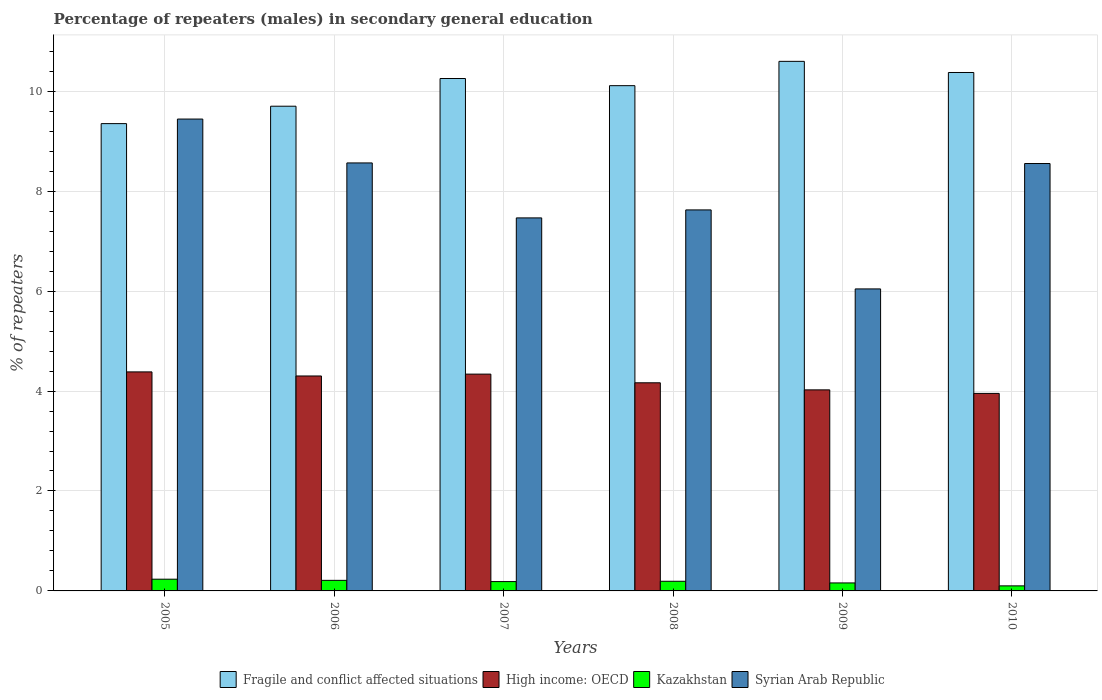How many different coloured bars are there?
Offer a terse response. 4. How many groups of bars are there?
Provide a succinct answer. 6. Are the number of bars on each tick of the X-axis equal?
Provide a succinct answer. Yes. How many bars are there on the 1st tick from the left?
Ensure brevity in your answer.  4. What is the label of the 1st group of bars from the left?
Make the answer very short. 2005. In how many cases, is the number of bars for a given year not equal to the number of legend labels?
Your answer should be very brief. 0. What is the percentage of male repeaters in High income: OECD in 2008?
Provide a succinct answer. 4.17. Across all years, what is the maximum percentage of male repeaters in Fragile and conflict affected situations?
Your response must be concise. 10.6. Across all years, what is the minimum percentage of male repeaters in High income: OECD?
Your answer should be compact. 3.95. What is the total percentage of male repeaters in Syrian Arab Republic in the graph?
Make the answer very short. 47.7. What is the difference between the percentage of male repeaters in High income: OECD in 2006 and that in 2009?
Your response must be concise. 0.28. What is the difference between the percentage of male repeaters in Fragile and conflict affected situations in 2005 and the percentage of male repeaters in Kazakhstan in 2006?
Provide a succinct answer. 9.14. What is the average percentage of male repeaters in Syrian Arab Republic per year?
Your answer should be very brief. 7.95. In the year 2006, what is the difference between the percentage of male repeaters in Syrian Arab Republic and percentage of male repeaters in High income: OECD?
Provide a short and direct response. 4.26. In how many years, is the percentage of male repeaters in Syrian Arab Republic greater than 0.4 %?
Offer a terse response. 6. What is the ratio of the percentage of male repeaters in Kazakhstan in 2005 to that in 2007?
Provide a short and direct response. 1.26. Is the difference between the percentage of male repeaters in Syrian Arab Republic in 2006 and 2009 greater than the difference between the percentage of male repeaters in High income: OECD in 2006 and 2009?
Give a very brief answer. Yes. What is the difference between the highest and the second highest percentage of male repeaters in Kazakhstan?
Ensure brevity in your answer.  0.02. What is the difference between the highest and the lowest percentage of male repeaters in Syrian Arab Republic?
Provide a succinct answer. 3.4. What does the 3rd bar from the left in 2009 represents?
Offer a very short reply. Kazakhstan. What does the 4th bar from the right in 2009 represents?
Your answer should be compact. Fragile and conflict affected situations. Is it the case that in every year, the sum of the percentage of male repeaters in High income: OECD and percentage of male repeaters in Syrian Arab Republic is greater than the percentage of male repeaters in Kazakhstan?
Your answer should be compact. Yes. What is the difference between two consecutive major ticks on the Y-axis?
Your response must be concise. 2. Does the graph contain grids?
Your answer should be compact. Yes. How many legend labels are there?
Your answer should be very brief. 4. How are the legend labels stacked?
Provide a succinct answer. Horizontal. What is the title of the graph?
Offer a terse response. Percentage of repeaters (males) in secondary general education. What is the label or title of the Y-axis?
Make the answer very short. % of repeaters. What is the % of repeaters in Fragile and conflict affected situations in 2005?
Your answer should be very brief. 9.35. What is the % of repeaters in High income: OECD in 2005?
Your answer should be very brief. 4.38. What is the % of repeaters of Kazakhstan in 2005?
Keep it short and to the point. 0.23. What is the % of repeaters of Syrian Arab Republic in 2005?
Your answer should be compact. 9.44. What is the % of repeaters in Fragile and conflict affected situations in 2006?
Offer a terse response. 9.7. What is the % of repeaters of High income: OECD in 2006?
Keep it short and to the point. 4.3. What is the % of repeaters of Kazakhstan in 2006?
Your response must be concise. 0.21. What is the % of repeaters of Syrian Arab Republic in 2006?
Provide a succinct answer. 8.57. What is the % of repeaters of Fragile and conflict affected situations in 2007?
Make the answer very short. 10.25. What is the % of repeaters in High income: OECD in 2007?
Offer a terse response. 4.34. What is the % of repeaters of Kazakhstan in 2007?
Offer a very short reply. 0.19. What is the % of repeaters in Syrian Arab Republic in 2007?
Ensure brevity in your answer.  7.47. What is the % of repeaters of Fragile and conflict affected situations in 2008?
Offer a terse response. 10.11. What is the % of repeaters in High income: OECD in 2008?
Your answer should be very brief. 4.17. What is the % of repeaters of Kazakhstan in 2008?
Ensure brevity in your answer.  0.19. What is the % of repeaters of Syrian Arab Republic in 2008?
Give a very brief answer. 7.63. What is the % of repeaters of Fragile and conflict affected situations in 2009?
Your response must be concise. 10.6. What is the % of repeaters of High income: OECD in 2009?
Your answer should be very brief. 4.02. What is the % of repeaters of Kazakhstan in 2009?
Offer a very short reply. 0.16. What is the % of repeaters in Syrian Arab Republic in 2009?
Give a very brief answer. 6.04. What is the % of repeaters in Fragile and conflict affected situations in 2010?
Offer a terse response. 10.38. What is the % of repeaters in High income: OECD in 2010?
Ensure brevity in your answer.  3.95. What is the % of repeaters in Kazakhstan in 2010?
Keep it short and to the point. 0.1. What is the % of repeaters in Syrian Arab Republic in 2010?
Offer a terse response. 8.55. Across all years, what is the maximum % of repeaters in Fragile and conflict affected situations?
Make the answer very short. 10.6. Across all years, what is the maximum % of repeaters of High income: OECD?
Make the answer very short. 4.38. Across all years, what is the maximum % of repeaters in Kazakhstan?
Your answer should be compact. 0.23. Across all years, what is the maximum % of repeaters in Syrian Arab Republic?
Your answer should be compact. 9.44. Across all years, what is the minimum % of repeaters in Fragile and conflict affected situations?
Your answer should be compact. 9.35. Across all years, what is the minimum % of repeaters in High income: OECD?
Provide a succinct answer. 3.95. Across all years, what is the minimum % of repeaters in Kazakhstan?
Your response must be concise. 0.1. Across all years, what is the minimum % of repeaters of Syrian Arab Republic?
Your response must be concise. 6.04. What is the total % of repeaters of Fragile and conflict affected situations in the graph?
Your response must be concise. 60.39. What is the total % of repeaters of High income: OECD in the graph?
Your response must be concise. 25.17. What is the total % of repeaters of Kazakhstan in the graph?
Your answer should be very brief. 1.09. What is the total % of repeaters of Syrian Arab Republic in the graph?
Provide a short and direct response. 47.7. What is the difference between the % of repeaters of Fragile and conflict affected situations in 2005 and that in 2006?
Your response must be concise. -0.35. What is the difference between the % of repeaters of High income: OECD in 2005 and that in 2006?
Your response must be concise. 0.08. What is the difference between the % of repeaters of Kazakhstan in 2005 and that in 2006?
Your answer should be compact. 0.02. What is the difference between the % of repeaters of Syrian Arab Republic in 2005 and that in 2006?
Your answer should be very brief. 0.88. What is the difference between the % of repeaters in Fragile and conflict affected situations in 2005 and that in 2007?
Give a very brief answer. -0.9. What is the difference between the % of repeaters in High income: OECD in 2005 and that in 2007?
Provide a succinct answer. 0.04. What is the difference between the % of repeaters in Kazakhstan in 2005 and that in 2007?
Make the answer very short. 0.05. What is the difference between the % of repeaters of Syrian Arab Republic in 2005 and that in 2007?
Give a very brief answer. 1.98. What is the difference between the % of repeaters in Fragile and conflict affected situations in 2005 and that in 2008?
Provide a short and direct response. -0.76. What is the difference between the % of repeaters in High income: OECD in 2005 and that in 2008?
Offer a terse response. 0.22. What is the difference between the % of repeaters of Kazakhstan in 2005 and that in 2008?
Offer a terse response. 0.04. What is the difference between the % of repeaters of Syrian Arab Republic in 2005 and that in 2008?
Offer a terse response. 1.82. What is the difference between the % of repeaters of Fragile and conflict affected situations in 2005 and that in 2009?
Your response must be concise. -1.25. What is the difference between the % of repeaters of High income: OECD in 2005 and that in 2009?
Your answer should be compact. 0.36. What is the difference between the % of repeaters of Kazakhstan in 2005 and that in 2009?
Your answer should be very brief. 0.07. What is the difference between the % of repeaters of Syrian Arab Republic in 2005 and that in 2009?
Ensure brevity in your answer.  3.4. What is the difference between the % of repeaters of Fragile and conflict affected situations in 2005 and that in 2010?
Give a very brief answer. -1.02. What is the difference between the % of repeaters of High income: OECD in 2005 and that in 2010?
Your response must be concise. 0.43. What is the difference between the % of repeaters in Kazakhstan in 2005 and that in 2010?
Offer a very short reply. 0.13. What is the difference between the % of repeaters of Syrian Arab Republic in 2005 and that in 2010?
Provide a succinct answer. 0.89. What is the difference between the % of repeaters in Fragile and conflict affected situations in 2006 and that in 2007?
Provide a succinct answer. -0.55. What is the difference between the % of repeaters in High income: OECD in 2006 and that in 2007?
Offer a very short reply. -0.04. What is the difference between the % of repeaters in Kazakhstan in 2006 and that in 2007?
Your answer should be compact. 0.02. What is the difference between the % of repeaters in Syrian Arab Republic in 2006 and that in 2007?
Offer a terse response. 1.1. What is the difference between the % of repeaters in Fragile and conflict affected situations in 2006 and that in 2008?
Make the answer very short. -0.41. What is the difference between the % of repeaters in High income: OECD in 2006 and that in 2008?
Ensure brevity in your answer.  0.14. What is the difference between the % of repeaters of Kazakhstan in 2006 and that in 2008?
Provide a short and direct response. 0.02. What is the difference between the % of repeaters of Syrian Arab Republic in 2006 and that in 2008?
Keep it short and to the point. 0.94. What is the difference between the % of repeaters of Fragile and conflict affected situations in 2006 and that in 2009?
Make the answer very short. -0.9. What is the difference between the % of repeaters in High income: OECD in 2006 and that in 2009?
Make the answer very short. 0.28. What is the difference between the % of repeaters of Kazakhstan in 2006 and that in 2009?
Your answer should be compact. 0.05. What is the difference between the % of repeaters in Syrian Arab Republic in 2006 and that in 2009?
Your response must be concise. 2.52. What is the difference between the % of repeaters of Fragile and conflict affected situations in 2006 and that in 2010?
Your answer should be compact. -0.67. What is the difference between the % of repeaters of High income: OECD in 2006 and that in 2010?
Keep it short and to the point. 0.35. What is the difference between the % of repeaters in Kazakhstan in 2006 and that in 2010?
Give a very brief answer. 0.11. What is the difference between the % of repeaters in Syrian Arab Republic in 2006 and that in 2010?
Provide a succinct answer. 0.01. What is the difference between the % of repeaters in Fragile and conflict affected situations in 2007 and that in 2008?
Make the answer very short. 0.14. What is the difference between the % of repeaters of High income: OECD in 2007 and that in 2008?
Offer a very short reply. 0.17. What is the difference between the % of repeaters in Kazakhstan in 2007 and that in 2008?
Give a very brief answer. -0.01. What is the difference between the % of repeaters of Syrian Arab Republic in 2007 and that in 2008?
Offer a very short reply. -0.16. What is the difference between the % of repeaters in Fragile and conflict affected situations in 2007 and that in 2009?
Your answer should be compact. -0.34. What is the difference between the % of repeaters of High income: OECD in 2007 and that in 2009?
Give a very brief answer. 0.32. What is the difference between the % of repeaters in Kazakhstan in 2007 and that in 2009?
Ensure brevity in your answer.  0.03. What is the difference between the % of repeaters of Syrian Arab Republic in 2007 and that in 2009?
Your answer should be very brief. 1.42. What is the difference between the % of repeaters of Fragile and conflict affected situations in 2007 and that in 2010?
Offer a very short reply. -0.12. What is the difference between the % of repeaters of High income: OECD in 2007 and that in 2010?
Provide a succinct answer. 0.39. What is the difference between the % of repeaters in Kazakhstan in 2007 and that in 2010?
Your answer should be very brief. 0.09. What is the difference between the % of repeaters of Syrian Arab Republic in 2007 and that in 2010?
Your answer should be compact. -1.09. What is the difference between the % of repeaters in Fragile and conflict affected situations in 2008 and that in 2009?
Your answer should be very brief. -0.49. What is the difference between the % of repeaters in High income: OECD in 2008 and that in 2009?
Offer a very short reply. 0.14. What is the difference between the % of repeaters of Kazakhstan in 2008 and that in 2009?
Give a very brief answer. 0.03. What is the difference between the % of repeaters in Syrian Arab Republic in 2008 and that in 2009?
Make the answer very short. 1.58. What is the difference between the % of repeaters of Fragile and conflict affected situations in 2008 and that in 2010?
Ensure brevity in your answer.  -0.26. What is the difference between the % of repeaters of High income: OECD in 2008 and that in 2010?
Provide a short and direct response. 0.21. What is the difference between the % of repeaters in Kazakhstan in 2008 and that in 2010?
Give a very brief answer. 0.09. What is the difference between the % of repeaters of Syrian Arab Republic in 2008 and that in 2010?
Make the answer very short. -0.93. What is the difference between the % of repeaters in Fragile and conflict affected situations in 2009 and that in 2010?
Ensure brevity in your answer.  0.22. What is the difference between the % of repeaters in High income: OECD in 2009 and that in 2010?
Offer a terse response. 0.07. What is the difference between the % of repeaters of Kazakhstan in 2009 and that in 2010?
Make the answer very short. 0.06. What is the difference between the % of repeaters in Syrian Arab Republic in 2009 and that in 2010?
Give a very brief answer. -2.51. What is the difference between the % of repeaters in Fragile and conflict affected situations in 2005 and the % of repeaters in High income: OECD in 2006?
Your answer should be compact. 5.05. What is the difference between the % of repeaters in Fragile and conflict affected situations in 2005 and the % of repeaters in Kazakhstan in 2006?
Provide a succinct answer. 9.14. What is the difference between the % of repeaters of Fragile and conflict affected situations in 2005 and the % of repeaters of Syrian Arab Republic in 2006?
Offer a very short reply. 0.79. What is the difference between the % of repeaters of High income: OECD in 2005 and the % of repeaters of Kazakhstan in 2006?
Make the answer very short. 4.17. What is the difference between the % of repeaters in High income: OECD in 2005 and the % of repeaters in Syrian Arab Republic in 2006?
Give a very brief answer. -4.18. What is the difference between the % of repeaters in Kazakhstan in 2005 and the % of repeaters in Syrian Arab Republic in 2006?
Offer a very short reply. -8.33. What is the difference between the % of repeaters in Fragile and conflict affected situations in 2005 and the % of repeaters in High income: OECD in 2007?
Keep it short and to the point. 5.01. What is the difference between the % of repeaters in Fragile and conflict affected situations in 2005 and the % of repeaters in Kazakhstan in 2007?
Your answer should be very brief. 9.17. What is the difference between the % of repeaters in Fragile and conflict affected situations in 2005 and the % of repeaters in Syrian Arab Republic in 2007?
Your answer should be very brief. 1.89. What is the difference between the % of repeaters of High income: OECD in 2005 and the % of repeaters of Kazakhstan in 2007?
Ensure brevity in your answer.  4.2. What is the difference between the % of repeaters in High income: OECD in 2005 and the % of repeaters in Syrian Arab Republic in 2007?
Offer a terse response. -3.08. What is the difference between the % of repeaters in Kazakhstan in 2005 and the % of repeaters in Syrian Arab Republic in 2007?
Provide a succinct answer. -7.23. What is the difference between the % of repeaters of Fragile and conflict affected situations in 2005 and the % of repeaters of High income: OECD in 2008?
Your answer should be very brief. 5.19. What is the difference between the % of repeaters in Fragile and conflict affected situations in 2005 and the % of repeaters in Kazakhstan in 2008?
Make the answer very short. 9.16. What is the difference between the % of repeaters of Fragile and conflict affected situations in 2005 and the % of repeaters of Syrian Arab Republic in 2008?
Ensure brevity in your answer.  1.73. What is the difference between the % of repeaters of High income: OECD in 2005 and the % of repeaters of Kazakhstan in 2008?
Offer a terse response. 4.19. What is the difference between the % of repeaters in High income: OECD in 2005 and the % of repeaters in Syrian Arab Republic in 2008?
Make the answer very short. -3.24. What is the difference between the % of repeaters of Kazakhstan in 2005 and the % of repeaters of Syrian Arab Republic in 2008?
Your answer should be compact. -7.39. What is the difference between the % of repeaters in Fragile and conflict affected situations in 2005 and the % of repeaters in High income: OECD in 2009?
Ensure brevity in your answer.  5.33. What is the difference between the % of repeaters of Fragile and conflict affected situations in 2005 and the % of repeaters of Kazakhstan in 2009?
Make the answer very short. 9.19. What is the difference between the % of repeaters in Fragile and conflict affected situations in 2005 and the % of repeaters in Syrian Arab Republic in 2009?
Offer a very short reply. 3.31. What is the difference between the % of repeaters in High income: OECD in 2005 and the % of repeaters in Kazakhstan in 2009?
Provide a short and direct response. 4.22. What is the difference between the % of repeaters of High income: OECD in 2005 and the % of repeaters of Syrian Arab Republic in 2009?
Your answer should be very brief. -1.66. What is the difference between the % of repeaters in Kazakhstan in 2005 and the % of repeaters in Syrian Arab Republic in 2009?
Provide a succinct answer. -5.81. What is the difference between the % of repeaters of Fragile and conflict affected situations in 2005 and the % of repeaters of High income: OECD in 2010?
Your answer should be very brief. 5.4. What is the difference between the % of repeaters in Fragile and conflict affected situations in 2005 and the % of repeaters in Kazakhstan in 2010?
Keep it short and to the point. 9.25. What is the difference between the % of repeaters of Fragile and conflict affected situations in 2005 and the % of repeaters of Syrian Arab Republic in 2010?
Offer a terse response. 0.8. What is the difference between the % of repeaters in High income: OECD in 2005 and the % of repeaters in Kazakhstan in 2010?
Ensure brevity in your answer.  4.28. What is the difference between the % of repeaters of High income: OECD in 2005 and the % of repeaters of Syrian Arab Republic in 2010?
Your response must be concise. -4.17. What is the difference between the % of repeaters of Kazakhstan in 2005 and the % of repeaters of Syrian Arab Republic in 2010?
Keep it short and to the point. -8.32. What is the difference between the % of repeaters in Fragile and conflict affected situations in 2006 and the % of repeaters in High income: OECD in 2007?
Offer a very short reply. 5.36. What is the difference between the % of repeaters in Fragile and conflict affected situations in 2006 and the % of repeaters in Kazakhstan in 2007?
Offer a terse response. 9.51. What is the difference between the % of repeaters in Fragile and conflict affected situations in 2006 and the % of repeaters in Syrian Arab Republic in 2007?
Ensure brevity in your answer.  2.24. What is the difference between the % of repeaters in High income: OECD in 2006 and the % of repeaters in Kazakhstan in 2007?
Offer a terse response. 4.11. What is the difference between the % of repeaters of High income: OECD in 2006 and the % of repeaters of Syrian Arab Republic in 2007?
Offer a terse response. -3.16. What is the difference between the % of repeaters of Kazakhstan in 2006 and the % of repeaters of Syrian Arab Republic in 2007?
Provide a succinct answer. -7.25. What is the difference between the % of repeaters of Fragile and conflict affected situations in 2006 and the % of repeaters of High income: OECD in 2008?
Provide a short and direct response. 5.54. What is the difference between the % of repeaters in Fragile and conflict affected situations in 2006 and the % of repeaters in Kazakhstan in 2008?
Ensure brevity in your answer.  9.51. What is the difference between the % of repeaters of Fragile and conflict affected situations in 2006 and the % of repeaters of Syrian Arab Republic in 2008?
Offer a terse response. 2.08. What is the difference between the % of repeaters of High income: OECD in 2006 and the % of repeaters of Kazakhstan in 2008?
Ensure brevity in your answer.  4.11. What is the difference between the % of repeaters of High income: OECD in 2006 and the % of repeaters of Syrian Arab Republic in 2008?
Offer a terse response. -3.32. What is the difference between the % of repeaters of Kazakhstan in 2006 and the % of repeaters of Syrian Arab Republic in 2008?
Offer a terse response. -7.41. What is the difference between the % of repeaters in Fragile and conflict affected situations in 2006 and the % of repeaters in High income: OECD in 2009?
Your answer should be very brief. 5.68. What is the difference between the % of repeaters of Fragile and conflict affected situations in 2006 and the % of repeaters of Kazakhstan in 2009?
Keep it short and to the point. 9.54. What is the difference between the % of repeaters in Fragile and conflict affected situations in 2006 and the % of repeaters in Syrian Arab Republic in 2009?
Provide a short and direct response. 3.66. What is the difference between the % of repeaters in High income: OECD in 2006 and the % of repeaters in Kazakhstan in 2009?
Provide a short and direct response. 4.14. What is the difference between the % of repeaters of High income: OECD in 2006 and the % of repeaters of Syrian Arab Republic in 2009?
Offer a very short reply. -1.74. What is the difference between the % of repeaters in Kazakhstan in 2006 and the % of repeaters in Syrian Arab Republic in 2009?
Offer a terse response. -5.83. What is the difference between the % of repeaters in Fragile and conflict affected situations in 2006 and the % of repeaters in High income: OECD in 2010?
Make the answer very short. 5.75. What is the difference between the % of repeaters of Fragile and conflict affected situations in 2006 and the % of repeaters of Kazakhstan in 2010?
Provide a succinct answer. 9.6. What is the difference between the % of repeaters in Fragile and conflict affected situations in 2006 and the % of repeaters in Syrian Arab Republic in 2010?
Your answer should be very brief. 1.15. What is the difference between the % of repeaters of High income: OECD in 2006 and the % of repeaters of Kazakhstan in 2010?
Offer a terse response. 4.2. What is the difference between the % of repeaters of High income: OECD in 2006 and the % of repeaters of Syrian Arab Republic in 2010?
Your answer should be compact. -4.25. What is the difference between the % of repeaters of Kazakhstan in 2006 and the % of repeaters of Syrian Arab Republic in 2010?
Offer a very short reply. -8.34. What is the difference between the % of repeaters of Fragile and conflict affected situations in 2007 and the % of repeaters of High income: OECD in 2008?
Make the answer very short. 6.09. What is the difference between the % of repeaters in Fragile and conflict affected situations in 2007 and the % of repeaters in Kazakhstan in 2008?
Provide a succinct answer. 10.06. What is the difference between the % of repeaters of Fragile and conflict affected situations in 2007 and the % of repeaters of Syrian Arab Republic in 2008?
Provide a succinct answer. 2.63. What is the difference between the % of repeaters of High income: OECD in 2007 and the % of repeaters of Kazakhstan in 2008?
Provide a succinct answer. 4.15. What is the difference between the % of repeaters in High income: OECD in 2007 and the % of repeaters in Syrian Arab Republic in 2008?
Provide a short and direct response. -3.29. What is the difference between the % of repeaters in Kazakhstan in 2007 and the % of repeaters in Syrian Arab Republic in 2008?
Offer a terse response. -7.44. What is the difference between the % of repeaters of Fragile and conflict affected situations in 2007 and the % of repeaters of High income: OECD in 2009?
Your answer should be compact. 6.23. What is the difference between the % of repeaters of Fragile and conflict affected situations in 2007 and the % of repeaters of Kazakhstan in 2009?
Your response must be concise. 10.09. What is the difference between the % of repeaters of Fragile and conflict affected situations in 2007 and the % of repeaters of Syrian Arab Republic in 2009?
Your answer should be very brief. 4.21. What is the difference between the % of repeaters of High income: OECD in 2007 and the % of repeaters of Kazakhstan in 2009?
Give a very brief answer. 4.18. What is the difference between the % of repeaters of High income: OECD in 2007 and the % of repeaters of Syrian Arab Republic in 2009?
Make the answer very short. -1.71. What is the difference between the % of repeaters in Kazakhstan in 2007 and the % of repeaters in Syrian Arab Republic in 2009?
Ensure brevity in your answer.  -5.86. What is the difference between the % of repeaters of Fragile and conflict affected situations in 2007 and the % of repeaters of High income: OECD in 2010?
Provide a short and direct response. 6.3. What is the difference between the % of repeaters of Fragile and conflict affected situations in 2007 and the % of repeaters of Kazakhstan in 2010?
Offer a terse response. 10.15. What is the difference between the % of repeaters of Fragile and conflict affected situations in 2007 and the % of repeaters of Syrian Arab Republic in 2010?
Keep it short and to the point. 1.7. What is the difference between the % of repeaters of High income: OECD in 2007 and the % of repeaters of Kazakhstan in 2010?
Provide a succinct answer. 4.24. What is the difference between the % of repeaters of High income: OECD in 2007 and the % of repeaters of Syrian Arab Republic in 2010?
Your response must be concise. -4.21. What is the difference between the % of repeaters of Kazakhstan in 2007 and the % of repeaters of Syrian Arab Republic in 2010?
Provide a succinct answer. -8.37. What is the difference between the % of repeaters in Fragile and conflict affected situations in 2008 and the % of repeaters in High income: OECD in 2009?
Give a very brief answer. 6.09. What is the difference between the % of repeaters of Fragile and conflict affected situations in 2008 and the % of repeaters of Kazakhstan in 2009?
Your answer should be very brief. 9.95. What is the difference between the % of repeaters in Fragile and conflict affected situations in 2008 and the % of repeaters in Syrian Arab Republic in 2009?
Ensure brevity in your answer.  4.07. What is the difference between the % of repeaters of High income: OECD in 2008 and the % of repeaters of Kazakhstan in 2009?
Ensure brevity in your answer.  4.01. What is the difference between the % of repeaters in High income: OECD in 2008 and the % of repeaters in Syrian Arab Republic in 2009?
Your answer should be compact. -1.88. What is the difference between the % of repeaters in Kazakhstan in 2008 and the % of repeaters in Syrian Arab Republic in 2009?
Your answer should be very brief. -5.85. What is the difference between the % of repeaters of Fragile and conflict affected situations in 2008 and the % of repeaters of High income: OECD in 2010?
Provide a short and direct response. 6.16. What is the difference between the % of repeaters of Fragile and conflict affected situations in 2008 and the % of repeaters of Kazakhstan in 2010?
Your answer should be compact. 10.01. What is the difference between the % of repeaters in Fragile and conflict affected situations in 2008 and the % of repeaters in Syrian Arab Republic in 2010?
Provide a short and direct response. 1.56. What is the difference between the % of repeaters in High income: OECD in 2008 and the % of repeaters in Kazakhstan in 2010?
Make the answer very short. 4.06. What is the difference between the % of repeaters in High income: OECD in 2008 and the % of repeaters in Syrian Arab Republic in 2010?
Provide a short and direct response. -4.39. What is the difference between the % of repeaters in Kazakhstan in 2008 and the % of repeaters in Syrian Arab Republic in 2010?
Give a very brief answer. -8.36. What is the difference between the % of repeaters in Fragile and conflict affected situations in 2009 and the % of repeaters in High income: OECD in 2010?
Your answer should be compact. 6.65. What is the difference between the % of repeaters of Fragile and conflict affected situations in 2009 and the % of repeaters of Kazakhstan in 2010?
Offer a very short reply. 10.5. What is the difference between the % of repeaters in Fragile and conflict affected situations in 2009 and the % of repeaters in Syrian Arab Republic in 2010?
Your response must be concise. 2.04. What is the difference between the % of repeaters in High income: OECD in 2009 and the % of repeaters in Kazakhstan in 2010?
Your answer should be very brief. 3.92. What is the difference between the % of repeaters of High income: OECD in 2009 and the % of repeaters of Syrian Arab Republic in 2010?
Your response must be concise. -4.53. What is the difference between the % of repeaters in Kazakhstan in 2009 and the % of repeaters in Syrian Arab Republic in 2010?
Your response must be concise. -8.39. What is the average % of repeaters of Fragile and conflict affected situations per year?
Keep it short and to the point. 10.07. What is the average % of repeaters in High income: OECD per year?
Give a very brief answer. 4.19. What is the average % of repeaters of Kazakhstan per year?
Your response must be concise. 0.18. What is the average % of repeaters of Syrian Arab Republic per year?
Provide a succinct answer. 7.95. In the year 2005, what is the difference between the % of repeaters in Fragile and conflict affected situations and % of repeaters in High income: OECD?
Your answer should be very brief. 4.97. In the year 2005, what is the difference between the % of repeaters of Fragile and conflict affected situations and % of repeaters of Kazakhstan?
Make the answer very short. 9.12. In the year 2005, what is the difference between the % of repeaters of Fragile and conflict affected situations and % of repeaters of Syrian Arab Republic?
Your answer should be very brief. -0.09. In the year 2005, what is the difference between the % of repeaters in High income: OECD and % of repeaters in Kazakhstan?
Provide a succinct answer. 4.15. In the year 2005, what is the difference between the % of repeaters in High income: OECD and % of repeaters in Syrian Arab Republic?
Give a very brief answer. -5.06. In the year 2005, what is the difference between the % of repeaters of Kazakhstan and % of repeaters of Syrian Arab Republic?
Give a very brief answer. -9.21. In the year 2006, what is the difference between the % of repeaters in Fragile and conflict affected situations and % of repeaters in High income: OECD?
Offer a terse response. 5.4. In the year 2006, what is the difference between the % of repeaters in Fragile and conflict affected situations and % of repeaters in Kazakhstan?
Ensure brevity in your answer.  9.49. In the year 2006, what is the difference between the % of repeaters in Fragile and conflict affected situations and % of repeaters in Syrian Arab Republic?
Give a very brief answer. 1.14. In the year 2006, what is the difference between the % of repeaters of High income: OECD and % of repeaters of Kazakhstan?
Provide a succinct answer. 4.09. In the year 2006, what is the difference between the % of repeaters in High income: OECD and % of repeaters in Syrian Arab Republic?
Your answer should be very brief. -4.26. In the year 2006, what is the difference between the % of repeaters in Kazakhstan and % of repeaters in Syrian Arab Republic?
Make the answer very short. -8.35. In the year 2007, what is the difference between the % of repeaters in Fragile and conflict affected situations and % of repeaters in High income: OECD?
Ensure brevity in your answer.  5.92. In the year 2007, what is the difference between the % of repeaters of Fragile and conflict affected situations and % of repeaters of Kazakhstan?
Ensure brevity in your answer.  10.07. In the year 2007, what is the difference between the % of repeaters in Fragile and conflict affected situations and % of repeaters in Syrian Arab Republic?
Offer a very short reply. 2.79. In the year 2007, what is the difference between the % of repeaters of High income: OECD and % of repeaters of Kazakhstan?
Give a very brief answer. 4.15. In the year 2007, what is the difference between the % of repeaters in High income: OECD and % of repeaters in Syrian Arab Republic?
Keep it short and to the point. -3.13. In the year 2007, what is the difference between the % of repeaters of Kazakhstan and % of repeaters of Syrian Arab Republic?
Make the answer very short. -7.28. In the year 2008, what is the difference between the % of repeaters in Fragile and conflict affected situations and % of repeaters in High income: OECD?
Offer a terse response. 5.95. In the year 2008, what is the difference between the % of repeaters of Fragile and conflict affected situations and % of repeaters of Kazakhstan?
Give a very brief answer. 9.92. In the year 2008, what is the difference between the % of repeaters in Fragile and conflict affected situations and % of repeaters in Syrian Arab Republic?
Ensure brevity in your answer.  2.49. In the year 2008, what is the difference between the % of repeaters in High income: OECD and % of repeaters in Kazakhstan?
Your response must be concise. 3.97. In the year 2008, what is the difference between the % of repeaters of High income: OECD and % of repeaters of Syrian Arab Republic?
Ensure brevity in your answer.  -3.46. In the year 2008, what is the difference between the % of repeaters in Kazakhstan and % of repeaters in Syrian Arab Republic?
Provide a short and direct response. -7.43. In the year 2009, what is the difference between the % of repeaters in Fragile and conflict affected situations and % of repeaters in High income: OECD?
Your response must be concise. 6.57. In the year 2009, what is the difference between the % of repeaters of Fragile and conflict affected situations and % of repeaters of Kazakhstan?
Make the answer very short. 10.44. In the year 2009, what is the difference between the % of repeaters in Fragile and conflict affected situations and % of repeaters in Syrian Arab Republic?
Your response must be concise. 4.55. In the year 2009, what is the difference between the % of repeaters in High income: OECD and % of repeaters in Kazakhstan?
Offer a very short reply. 3.86. In the year 2009, what is the difference between the % of repeaters in High income: OECD and % of repeaters in Syrian Arab Republic?
Your response must be concise. -2.02. In the year 2009, what is the difference between the % of repeaters in Kazakhstan and % of repeaters in Syrian Arab Republic?
Keep it short and to the point. -5.88. In the year 2010, what is the difference between the % of repeaters of Fragile and conflict affected situations and % of repeaters of High income: OECD?
Ensure brevity in your answer.  6.42. In the year 2010, what is the difference between the % of repeaters of Fragile and conflict affected situations and % of repeaters of Kazakhstan?
Your answer should be very brief. 10.27. In the year 2010, what is the difference between the % of repeaters in Fragile and conflict affected situations and % of repeaters in Syrian Arab Republic?
Provide a short and direct response. 1.82. In the year 2010, what is the difference between the % of repeaters of High income: OECD and % of repeaters of Kazakhstan?
Your response must be concise. 3.85. In the year 2010, what is the difference between the % of repeaters of High income: OECD and % of repeaters of Syrian Arab Republic?
Give a very brief answer. -4.6. In the year 2010, what is the difference between the % of repeaters in Kazakhstan and % of repeaters in Syrian Arab Republic?
Your response must be concise. -8.45. What is the ratio of the % of repeaters of Fragile and conflict affected situations in 2005 to that in 2006?
Give a very brief answer. 0.96. What is the ratio of the % of repeaters in High income: OECD in 2005 to that in 2006?
Keep it short and to the point. 1.02. What is the ratio of the % of repeaters of Kazakhstan in 2005 to that in 2006?
Make the answer very short. 1.11. What is the ratio of the % of repeaters in Syrian Arab Republic in 2005 to that in 2006?
Give a very brief answer. 1.1. What is the ratio of the % of repeaters of Fragile and conflict affected situations in 2005 to that in 2007?
Provide a succinct answer. 0.91. What is the ratio of the % of repeaters of High income: OECD in 2005 to that in 2007?
Your answer should be very brief. 1.01. What is the ratio of the % of repeaters of Kazakhstan in 2005 to that in 2007?
Your response must be concise. 1.26. What is the ratio of the % of repeaters in Syrian Arab Republic in 2005 to that in 2007?
Give a very brief answer. 1.26. What is the ratio of the % of repeaters in Fragile and conflict affected situations in 2005 to that in 2008?
Your answer should be compact. 0.92. What is the ratio of the % of repeaters of High income: OECD in 2005 to that in 2008?
Your answer should be compact. 1.05. What is the ratio of the % of repeaters in Kazakhstan in 2005 to that in 2008?
Your response must be concise. 1.22. What is the ratio of the % of repeaters in Syrian Arab Republic in 2005 to that in 2008?
Provide a short and direct response. 1.24. What is the ratio of the % of repeaters of Fragile and conflict affected situations in 2005 to that in 2009?
Ensure brevity in your answer.  0.88. What is the ratio of the % of repeaters in High income: OECD in 2005 to that in 2009?
Ensure brevity in your answer.  1.09. What is the ratio of the % of repeaters in Kazakhstan in 2005 to that in 2009?
Make the answer very short. 1.47. What is the ratio of the % of repeaters of Syrian Arab Republic in 2005 to that in 2009?
Your answer should be very brief. 1.56. What is the ratio of the % of repeaters in Fragile and conflict affected situations in 2005 to that in 2010?
Your answer should be very brief. 0.9. What is the ratio of the % of repeaters in High income: OECD in 2005 to that in 2010?
Provide a short and direct response. 1.11. What is the ratio of the % of repeaters of Kazakhstan in 2005 to that in 2010?
Provide a short and direct response. 2.32. What is the ratio of the % of repeaters of Syrian Arab Republic in 2005 to that in 2010?
Keep it short and to the point. 1.1. What is the ratio of the % of repeaters of Fragile and conflict affected situations in 2006 to that in 2007?
Offer a very short reply. 0.95. What is the ratio of the % of repeaters of High income: OECD in 2006 to that in 2007?
Your answer should be compact. 0.99. What is the ratio of the % of repeaters in Kazakhstan in 2006 to that in 2007?
Give a very brief answer. 1.13. What is the ratio of the % of repeaters of Syrian Arab Republic in 2006 to that in 2007?
Provide a short and direct response. 1.15. What is the ratio of the % of repeaters in Fragile and conflict affected situations in 2006 to that in 2008?
Give a very brief answer. 0.96. What is the ratio of the % of repeaters of High income: OECD in 2006 to that in 2008?
Keep it short and to the point. 1.03. What is the ratio of the % of repeaters of Kazakhstan in 2006 to that in 2008?
Your answer should be very brief. 1.1. What is the ratio of the % of repeaters in Syrian Arab Republic in 2006 to that in 2008?
Provide a succinct answer. 1.12. What is the ratio of the % of repeaters in Fragile and conflict affected situations in 2006 to that in 2009?
Give a very brief answer. 0.92. What is the ratio of the % of repeaters in High income: OECD in 2006 to that in 2009?
Offer a very short reply. 1.07. What is the ratio of the % of repeaters in Kazakhstan in 2006 to that in 2009?
Offer a very short reply. 1.32. What is the ratio of the % of repeaters of Syrian Arab Republic in 2006 to that in 2009?
Keep it short and to the point. 1.42. What is the ratio of the % of repeaters of Fragile and conflict affected situations in 2006 to that in 2010?
Offer a terse response. 0.94. What is the ratio of the % of repeaters in High income: OECD in 2006 to that in 2010?
Your answer should be very brief. 1.09. What is the ratio of the % of repeaters in Kazakhstan in 2006 to that in 2010?
Provide a succinct answer. 2.09. What is the ratio of the % of repeaters in Syrian Arab Republic in 2006 to that in 2010?
Make the answer very short. 1. What is the ratio of the % of repeaters of Fragile and conflict affected situations in 2007 to that in 2008?
Your answer should be compact. 1.01. What is the ratio of the % of repeaters of High income: OECD in 2007 to that in 2008?
Your answer should be very brief. 1.04. What is the ratio of the % of repeaters of Kazakhstan in 2007 to that in 2008?
Your answer should be compact. 0.97. What is the ratio of the % of repeaters in Fragile and conflict affected situations in 2007 to that in 2009?
Your response must be concise. 0.97. What is the ratio of the % of repeaters in High income: OECD in 2007 to that in 2009?
Your response must be concise. 1.08. What is the ratio of the % of repeaters of Kazakhstan in 2007 to that in 2009?
Your response must be concise. 1.17. What is the ratio of the % of repeaters in Syrian Arab Republic in 2007 to that in 2009?
Make the answer very short. 1.24. What is the ratio of the % of repeaters in Fragile and conflict affected situations in 2007 to that in 2010?
Your answer should be compact. 0.99. What is the ratio of the % of repeaters in High income: OECD in 2007 to that in 2010?
Offer a terse response. 1.1. What is the ratio of the % of repeaters of Kazakhstan in 2007 to that in 2010?
Your response must be concise. 1.85. What is the ratio of the % of repeaters in Syrian Arab Republic in 2007 to that in 2010?
Provide a succinct answer. 0.87. What is the ratio of the % of repeaters of Fragile and conflict affected situations in 2008 to that in 2009?
Provide a short and direct response. 0.95. What is the ratio of the % of repeaters of High income: OECD in 2008 to that in 2009?
Your answer should be very brief. 1.04. What is the ratio of the % of repeaters in Kazakhstan in 2008 to that in 2009?
Provide a succinct answer. 1.21. What is the ratio of the % of repeaters of Syrian Arab Republic in 2008 to that in 2009?
Keep it short and to the point. 1.26. What is the ratio of the % of repeaters in Fragile and conflict affected situations in 2008 to that in 2010?
Give a very brief answer. 0.97. What is the ratio of the % of repeaters in High income: OECD in 2008 to that in 2010?
Your response must be concise. 1.05. What is the ratio of the % of repeaters of Kazakhstan in 2008 to that in 2010?
Offer a very short reply. 1.91. What is the ratio of the % of repeaters of Syrian Arab Republic in 2008 to that in 2010?
Offer a very short reply. 0.89. What is the ratio of the % of repeaters of Fragile and conflict affected situations in 2009 to that in 2010?
Your response must be concise. 1.02. What is the ratio of the % of repeaters in High income: OECD in 2009 to that in 2010?
Offer a very short reply. 1.02. What is the ratio of the % of repeaters in Kazakhstan in 2009 to that in 2010?
Offer a very short reply. 1.58. What is the ratio of the % of repeaters in Syrian Arab Republic in 2009 to that in 2010?
Ensure brevity in your answer.  0.71. What is the difference between the highest and the second highest % of repeaters of Fragile and conflict affected situations?
Your response must be concise. 0.22. What is the difference between the highest and the second highest % of repeaters of High income: OECD?
Provide a succinct answer. 0.04. What is the difference between the highest and the second highest % of repeaters of Kazakhstan?
Offer a very short reply. 0.02. What is the difference between the highest and the second highest % of repeaters in Syrian Arab Republic?
Your answer should be very brief. 0.88. What is the difference between the highest and the lowest % of repeaters of Fragile and conflict affected situations?
Your answer should be compact. 1.25. What is the difference between the highest and the lowest % of repeaters in High income: OECD?
Ensure brevity in your answer.  0.43. What is the difference between the highest and the lowest % of repeaters of Kazakhstan?
Your answer should be compact. 0.13. What is the difference between the highest and the lowest % of repeaters in Syrian Arab Republic?
Give a very brief answer. 3.4. 